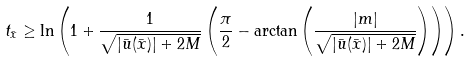<formula> <loc_0><loc_0><loc_500><loc_500>t _ { \bar { x } } \geq \ln \left ( 1 + \frac { 1 } { \sqrt { | \bar { u } ( \bar { x } ) | + 2 M } } \left ( \frac { \pi } { 2 } - \arctan \left ( \frac { | m | } { \sqrt { | \bar { u } ( \bar { x } ) | + 2 M } } \right ) \right ) \right ) .</formula> 